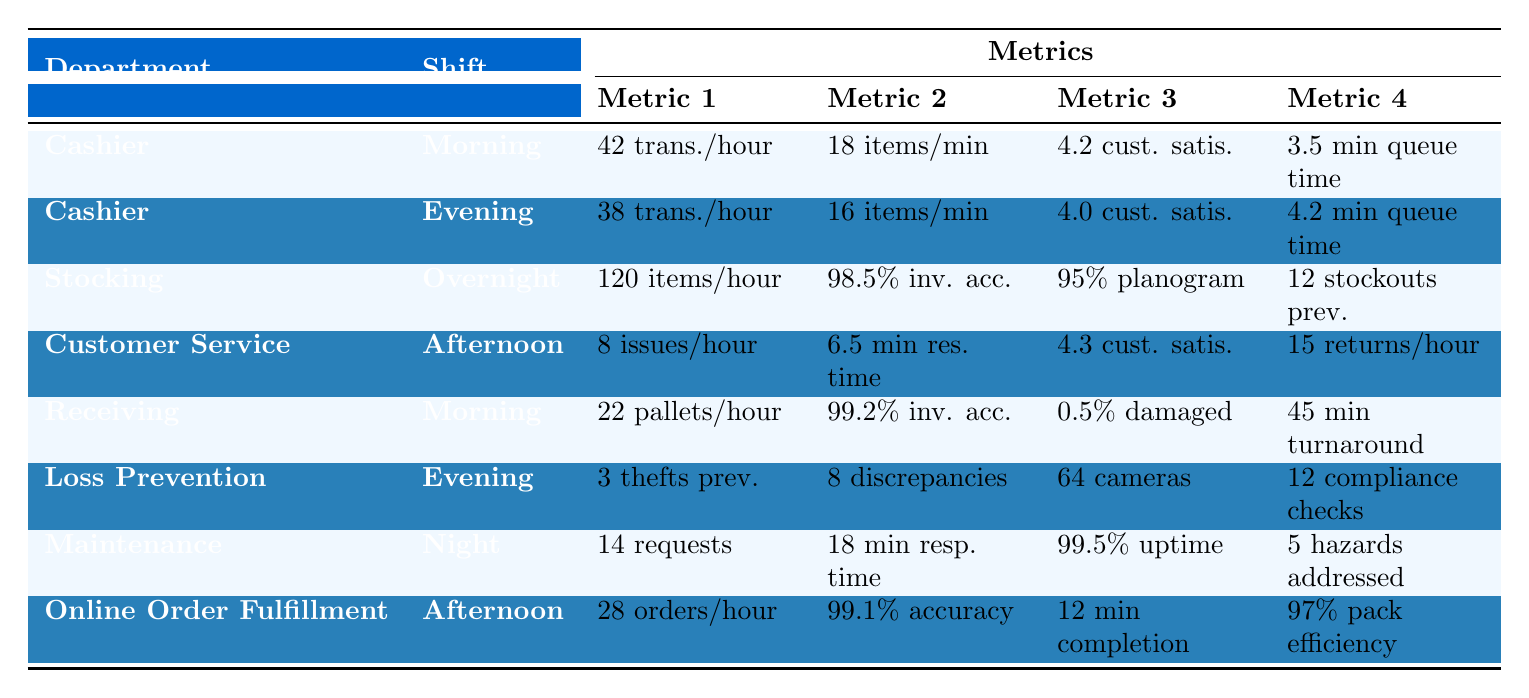What is the customer satisfaction score for the Cashier department during the Morning shift? Referring to the table, under the Cashier department's Morning shift, the customer satisfaction score is listed as 4.2.
Answer: 4.2 How many transactions per hour does the Cashier department handle during the Evening shift? The table shows that during the Evening shift in the Cashier department, the transactions per hour amount to 38.
Answer: 38 What is the average queue time for customers at the Cashier department during the Evening shift? The average queue time listed for the Evening shift under Cashier is 4.2 minutes.
Answer: 4.2 minutes Which department has the highest items stocked per hour? Looking at the table, the Stocking department during the Overnight shift stocks 120 items per hour, which is the highest.
Answer: 120 How many issues does the Customer Service department resolve per hour during the Afternoon shift? In the Afternoon shift for the Customer Service department, it resolves 8 issues per hour as per the table.
Answer: 8 What is the average resolution time for issues in the Customer Service department during the Afternoon shift? The average resolution time for issues in the Afternoon shift under Customer Service is 6.5 minutes.
Answer: 6.5 minutes Is the inventory accuracy percentage for the Receiving department higher during the Morning shift than that for the Stocking department during the Overnight shift? The Receiving department has an inventory accuracy of 99.2% in the Morning shift, and the Stocking department has 98.5%. Since 99.2% is higher than 98.5%, the statement is true.
Answer: Yes Which department has the lowest customer satisfaction score, and what is that score? The Cashier department during the Evening shift has the lowest customer satisfaction score at 4.0.
Answer: Cashier Evening; 4.0 How many stockouts does the Stocking department prevent per shift? According to the table, the Stocking department prevents 12 stockouts per shift.
Answer: 12 If the average maintenance response time is 18 minutes and the number of maintenance requests completed is 14, what total average time is spent on maintaining equipment during the night? Given that the average response time is 18 minutes per request, for 14 requests the total time is 14 * 18 = 252 minutes spent on maintenance.
Answer: 252 minutes What is the difference in average queue time between the Cashier department in the Morning and Evening shifts? The average queue time for the Morning shift is 3.5 minutes and for the Evening shift is 4.2 minutes. The difference is 4.2 - 3.5 = 0.7 minutes.
Answer: 0.7 minutes Is there a higher number of pallets unloaded in the Receiving department during the Morning shift compared to the items scanned in the Cashier department during the Morning shift? The Receiving department unloads 22 pallets per hour, while the Cashier department scans 18 items per minute, converting to 18 * 60 = 1080 items per hour. Since 1080 is higher than 22, the answer is no.
Answer: No How many security cameras are monitored by the Loss Prevention department during the Evening shift? The table indicates that during the Evening shift, the Loss Prevention department monitors 64 security cameras.
Answer: 64 What is the packing efficiency percentage for the Online Order Fulfillment department in the Afternoon shift? The packing efficiency percentage for Online Order Fulfillment during the Afternoon shift is reported as 97%.
Answer: 97% 